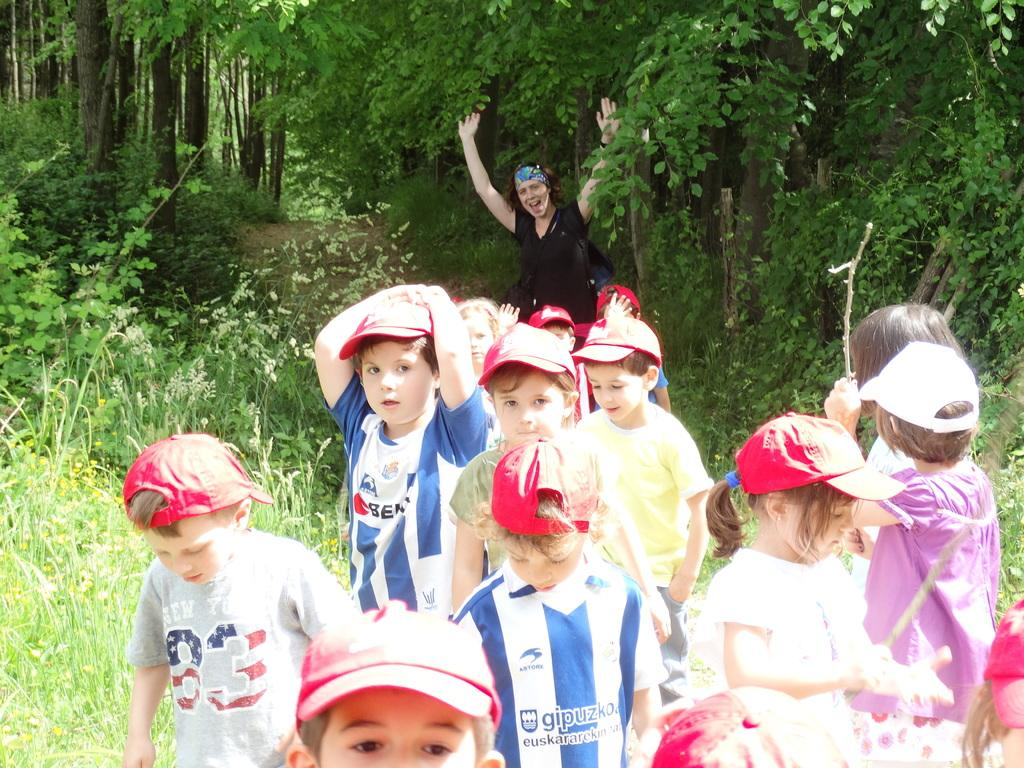What is the main subject of the image? The main subject of the image is a group of kids. Is there anyone else present in the image besides the kids? Yes, there is a person in the image. What can be seen in the background of the image? There are trees and grass in the background of the image. What type of attraction is present in the image? There is no attraction present in the image; it features a group of kids and a person in a natural setting. What force is being applied to the kids in the image? There is no force being applied to the kids in the image; they are simply standing or interacting with each other. 